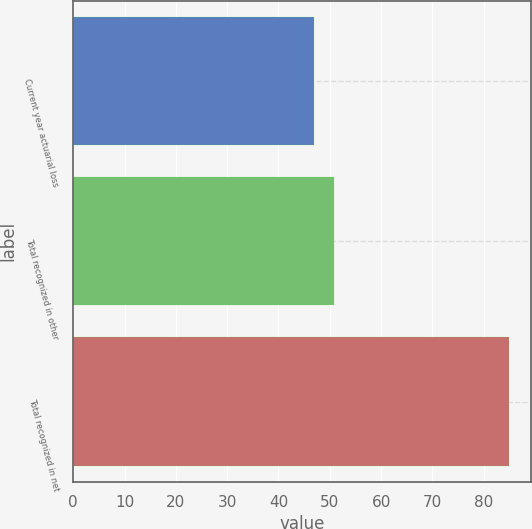Convert chart. <chart><loc_0><loc_0><loc_500><loc_500><bar_chart><fcel>Current year actuarial loss<fcel>Total recognized in other<fcel>Total recognized in net<nl><fcel>47<fcel>50.8<fcel>85<nl></chart> 